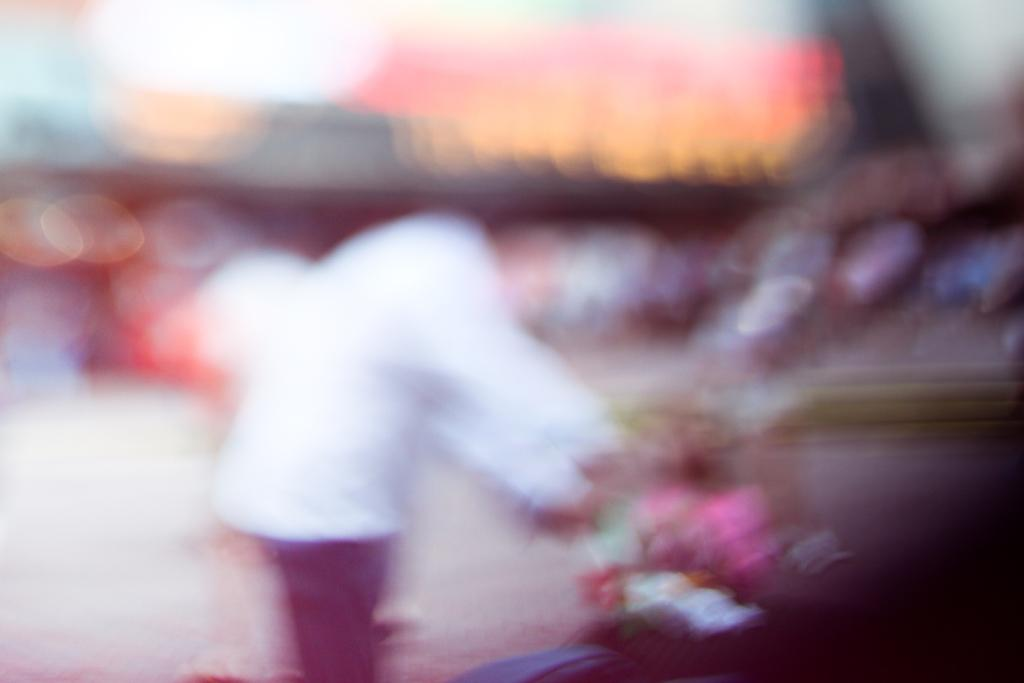Can you describe the quality of the image? The image is blurry. What type of wealth is displayed in the image? There is no wealth displayed in the image, as it is blurry and the content cannot be determined. 